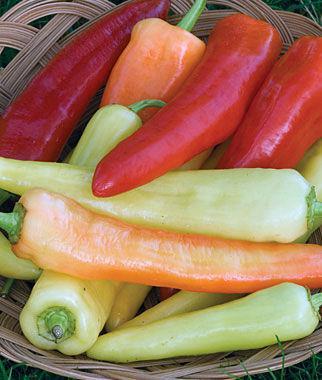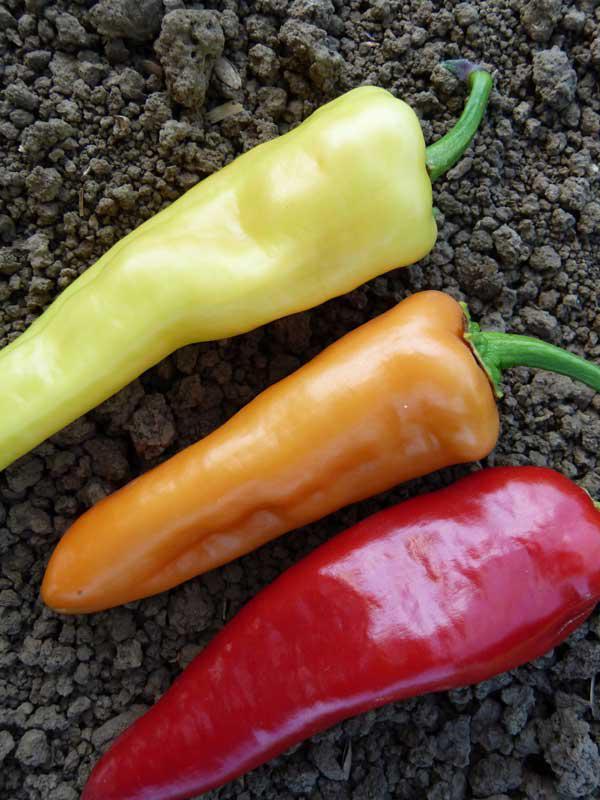The first image is the image on the left, the second image is the image on the right. For the images shown, is this caption "The right image shows a neat row of picked peppers that includes red, orange, and yellow color varieties." true? Answer yes or no. Yes. The first image is the image on the left, the second image is the image on the right. Examine the images to the left and right. Is the description "Both images in the pair show hot peppers that are yellow, orange, red, and green." accurate? Answer yes or no. Yes. 